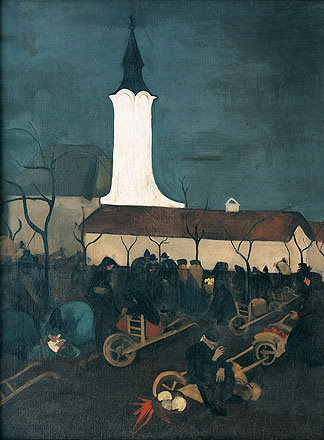What's happening in the scene? This oil painting captures a night scene at a village church. The church, with its distinct and illuminated white steeple, stands out against the twilight sky. The landscape is alive with villagers, who appear busy with nocturnal activities, possibly preparing for an observatory event, as suggested by the presence of ladders and other objects. People are clothed in period attire, suggesting this could be a historical portrayal. The scene's ambiance is reflective of post-impressionist styles with its dark hues and expressive brushstrokes, adding dynamism and emotional depth to the depiction. 